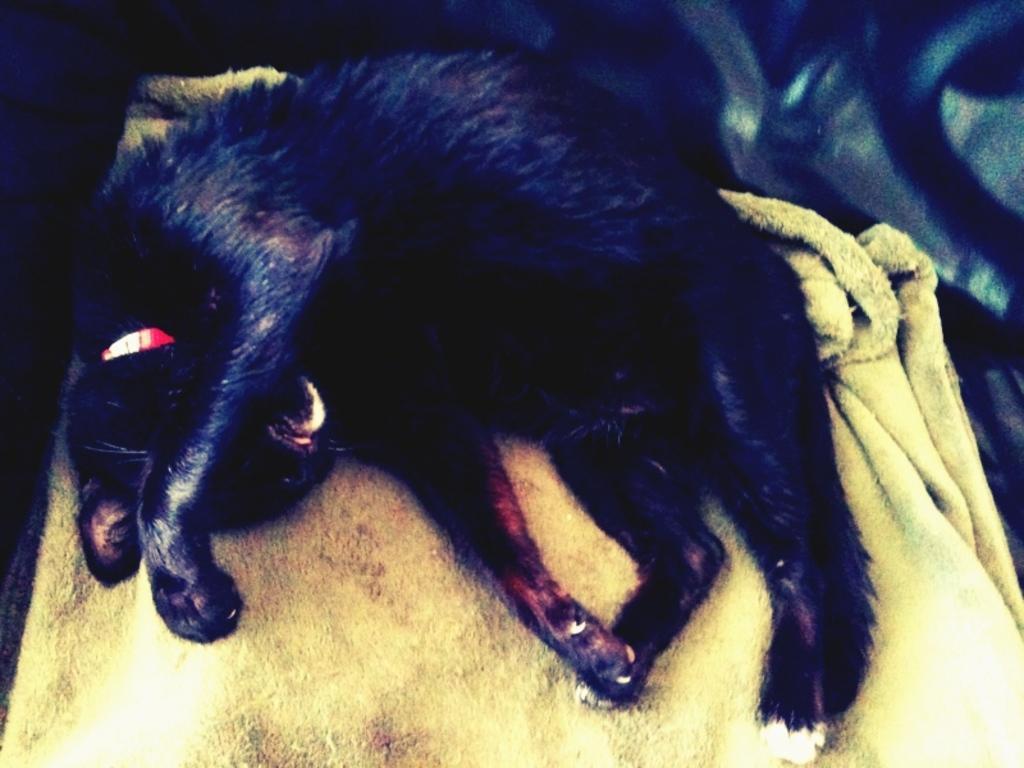Describe this image in one or two sentences. In this picture I can see a black color cat on the cloth and I can see a red color belt on its neck. 